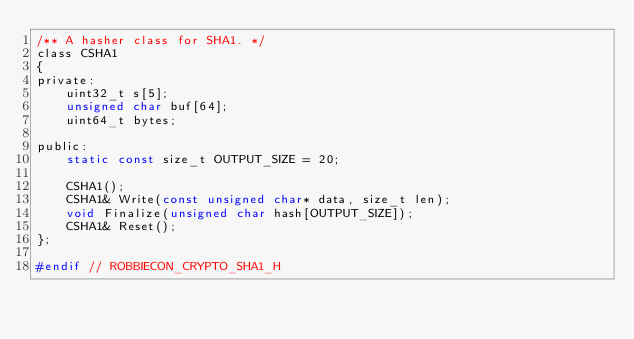<code> <loc_0><loc_0><loc_500><loc_500><_C_>/** A hasher class for SHA1. */
class CSHA1
{
private:
    uint32_t s[5];
    unsigned char buf[64];
    uint64_t bytes;

public:
    static const size_t OUTPUT_SIZE = 20;

    CSHA1();
    CSHA1& Write(const unsigned char* data, size_t len);
    void Finalize(unsigned char hash[OUTPUT_SIZE]);
    CSHA1& Reset();
};

#endif // ROBBIECON_CRYPTO_SHA1_H
</code> 